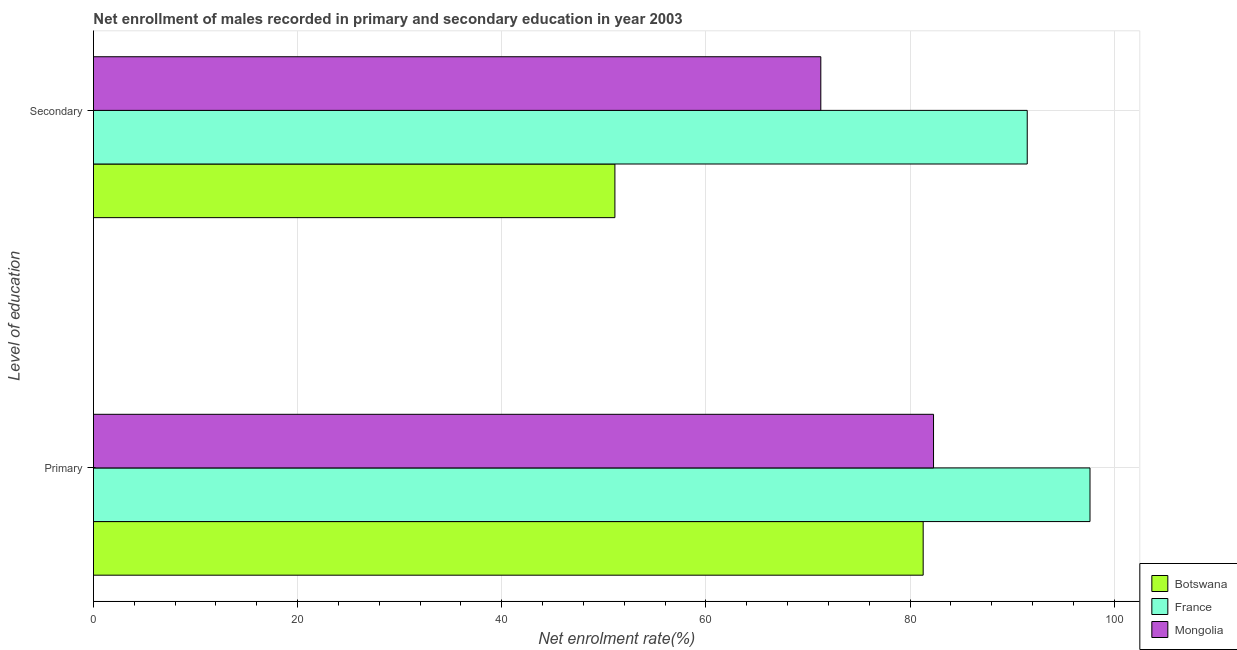How many groups of bars are there?
Keep it short and to the point. 2. Are the number of bars per tick equal to the number of legend labels?
Offer a very short reply. Yes. Are the number of bars on each tick of the Y-axis equal?
Keep it short and to the point. Yes. How many bars are there on the 1st tick from the top?
Provide a short and direct response. 3. How many bars are there on the 2nd tick from the bottom?
Your answer should be very brief. 3. What is the label of the 1st group of bars from the top?
Provide a short and direct response. Secondary. What is the enrollment rate in primary education in Mongolia?
Ensure brevity in your answer.  82.31. Across all countries, what is the maximum enrollment rate in primary education?
Provide a succinct answer. 97.64. Across all countries, what is the minimum enrollment rate in secondary education?
Your answer should be compact. 51.09. In which country was the enrollment rate in primary education maximum?
Provide a short and direct response. France. In which country was the enrollment rate in primary education minimum?
Give a very brief answer. Botswana. What is the total enrollment rate in primary education in the graph?
Provide a succinct answer. 261.23. What is the difference between the enrollment rate in secondary education in France and that in Botswana?
Keep it short and to the point. 40.4. What is the difference between the enrollment rate in secondary education in France and the enrollment rate in primary education in Mongolia?
Provide a succinct answer. 9.18. What is the average enrollment rate in secondary education per country?
Provide a short and direct response. 71.28. What is the difference between the enrollment rate in secondary education and enrollment rate in primary education in France?
Give a very brief answer. -6.15. In how many countries, is the enrollment rate in primary education greater than 32 %?
Your answer should be compact. 3. What is the ratio of the enrollment rate in primary education in France to that in Botswana?
Your response must be concise. 1.2. In how many countries, is the enrollment rate in primary education greater than the average enrollment rate in primary education taken over all countries?
Give a very brief answer. 1. What does the 1st bar from the top in Secondary represents?
Offer a very short reply. Mongolia. What does the 1st bar from the bottom in Primary represents?
Make the answer very short. Botswana. Are all the bars in the graph horizontal?
Offer a very short reply. Yes. How many countries are there in the graph?
Provide a succinct answer. 3. Are the values on the major ticks of X-axis written in scientific E-notation?
Keep it short and to the point. No. Does the graph contain grids?
Provide a short and direct response. Yes. How many legend labels are there?
Give a very brief answer. 3. What is the title of the graph?
Provide a short and direct response. Net enrollment of males recorded in primary and secondary education in year 2003. What is the label or title of the X-axis?
Your response must be concise. Net enrolment rate(%). What is the label or title of the Y-axis?
Keep it short and to the point. Level of education. What is the Net enrolment rate(%) of Botswana in Primary?
Provide a succinct answer. 81.29. What is the Net enrolment rate(%) in France in Primary?
Provide a short and direct response. 97.64. What is the Net enrolment rate(%) in Mongolia in Primary?
Ensure brevity in your answer.  82.31. What is the Net enrolment rate(%) of Botswana in Secondary?
Make the answer very short. 51.09. What is the Net enrolment rate(%) in France in Secondary?
Ensure brevity in your answer.  91.49. What is the Net enrolment rate(%) of Mongolia in Secondary?
Offer a terse response. 71.26. Across all Level of education, what is the maximum Net enrolment rate(%) of Botswana?
Your response must be concise. 81.29. Across all Level of education, what is the maximum Net enrolment rate(%) of France?
Give a very brief answer. 97.64. Across all Level of education, what is the maximum Net enrolment rate(%) in Mongolia?
Provide a short and direct response. 82.31. Across all Level of education, what is the minimum Net enrolment rate(%) of Botswana?
Keep it short and to the point. 51.09. Across all Level of education, what is the minimum Net enrolment rate(%) of France?
Give a very brief answer. 91.49. Across all Level of education, what is the minimum Net enrolment rate(%) of Mongolia?
Give a very brief answer. 71.26. What is the total Net enrolment rate(%) in Botswana in the graph?
Ensure brevity in your answer.  132.38. What is the total Net enrolment rate(%) in France in the graph?
Your answer should be compact. 189.12. What is the total Net enrolment rate(%) of Mongolia in the graph?
Give a very brief answer. 153.57. What is the difference between the Net enrolment rate(%) in Botswana in Primary and that in Secondary?
Give a very brief answer. 30.2. What is the difference between the Net enrolment rate(%) of France in Primary and that in Secondary?
Your response must be concise. 6.15. What is the difference between the Net enrolment rate(%) of Mongolia in Primary and that in Secondary?
Offer a terse response. 11.04. What is the difference between the Net enrolment rate(%) of Botswana in Primary and the Net enrolment rate(%) of France in Secondary?
Your answer should be very brief. -10.2. What is the difference between the Net enrolment rate(%) in Botswana in Primary and the Net enrolment rate(%) in Mongolia in Secondary?
Give a very brief answer. 10.03. What is the difference between the Net enrolment rate(%) in France in Primary and the Net enrolment rate(%) in Mongolia in Secondary?
Provide a succinct answer. 26.37. What is the average Net enrolment rate(%) of Botswana per Level of education?
Your response must be concise. 66.19. What is the average Net enrolment rate(%) of France per Level of education?
Keep it short and to the point. 94.56. What is the average Net enrolment rate(%) in Mongolia per Level of education?
Your response must be concise. 76.78. What is the difference between the Net enrolment rate(%) in Botswana and Net enrolment rate(%) in France in Primary?
Provide a succinct answer. -16.35. What is the difference between the Net enrolment rate(%) in Botswana and Net enrolment rate(%) in Mongolia in Primary?
Provide a succinct answer. -1.02. What is the difference between the Net enrolment rate(%) in France and Net enrolment rate(%) in Mongolia in Primary?
Offer a terse response. 15.33. What is the difference between the Net enrolment rate(%) of Botswana and Net enrolment rate(%) of France in Secondary?
Give a very brief answer. -40.4. What is the difference between the Net enrolment rate(%) in Botswana and Net enrolment rate(%) in Mongolia in Secondary?
Give a very brief answer. -20.17. What is the difference between the Net enrolment rate(%) in France and Net enrolment rate(%) in Mongolia in Secondary?
Keep it short and to the point. 20.23. What is the ratio of the Net enrolment rate(%) in Botswana in Primary to that in Secondary?
Keep it short and to the point. 1.59. What is the ratio of the Net enrolment rate(%) in France in Primary to that in Secondary?
Your answer should be compact. 1.07. What is the ratio of the Net enrolment rate(%) in Mongolia in Primary to that in Secondary?
Ensure brevity in your answer.  1.16. What is the difference between the highest and the second highest Net enrolment rate(%) of Botswana?
Give a very brief answer. 30.2. What is the difference between the highest and the second highest Net enrolment rate(%) of France?
Offer a terse response. 6.15. What is the difference between the highest and the second highest Net enrolment rate(%) of Mongolia?
Keep it short and to the point. 11.04. What is the difference between the highest and the lowest Net enrolment rate(%) in Botswana?
Ensure brevity in your answer.  30.2. What is the difference between the highest and the lowest Net enrolment rate(%) of France?
Your response must be concise. 6.15. What is the difference between the highest and the lowest Net enrolment rate(%) in Mongolia?
Ensure brevity in your answer.  11.04. 